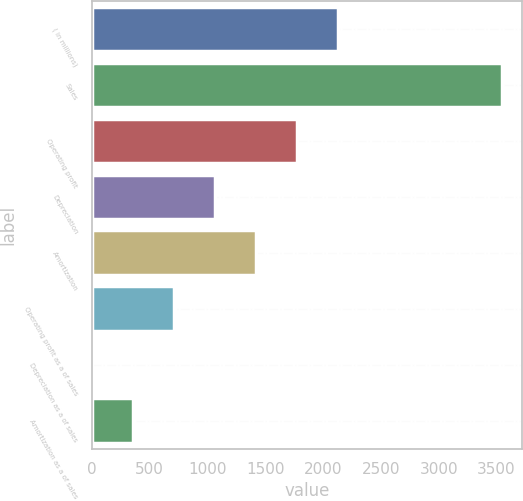Convert chart to OTSL. <chart><loc_0><loc_0><loc_500><loc_500><bar_chart><fcel>( in millions)<fcel>Sales<fcel>Operating profit<fcel>Depreciation<fcel>Amortization<fcel>Operating profit as a of sales<fcel>Depreciation as a of sales<fcel>Amortization as a of sales<nl><fcel>2126.5<fcel>3543.5<fcel>1772.25<fcel>1063.75<fcel>1418<fcel>709.5<fcel>1<fcel>355.25<nl></chart> 